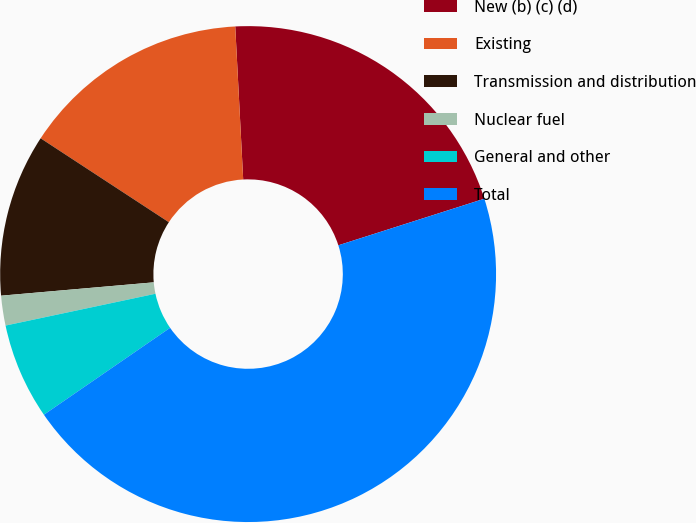Convert chart to OTSL. <chart><loc_0><loc_0><loc_500><loc_500><pie_chart><fcel>New (b) (c) (d)<fcel>Existing<fcel>Transmission and distribution<fcel>Nuclear fuel<fcel>General and other<fcel>Total<nl><fcel>20.91%<fcel>14.95%<fcel>10.61%<fcel>1.94%<fcel>6.27%<fcel>45.31%<nl></chart> 